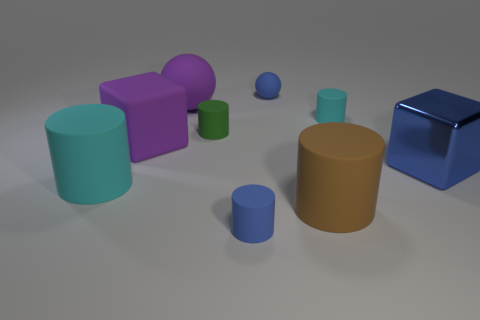Subtract all green rubber cylinders. How many cylinders are left? 4 Subtract all blue cubes. How many cubes are left? 1 Subtract all spheres. How many objects are left? 7 Subtract 1 cylinders. How many cylinders are left? 4 Subtract 1 blue cubes. How many objects are left? 8 Subtract all cyan cubes. Subtract all yellow cylinders. How many cubes are left? 2 Subtract all cyan spheres. How many blue blocks are left? 1 Subtract all brown rubber cylinders. Subtract all blue matte balls. How many objects are left? 7 Add 7 big purple rubber cubes. How many big purple rubber cubes are left? 8 Add 5 green objects. How many green objects exist? 6 